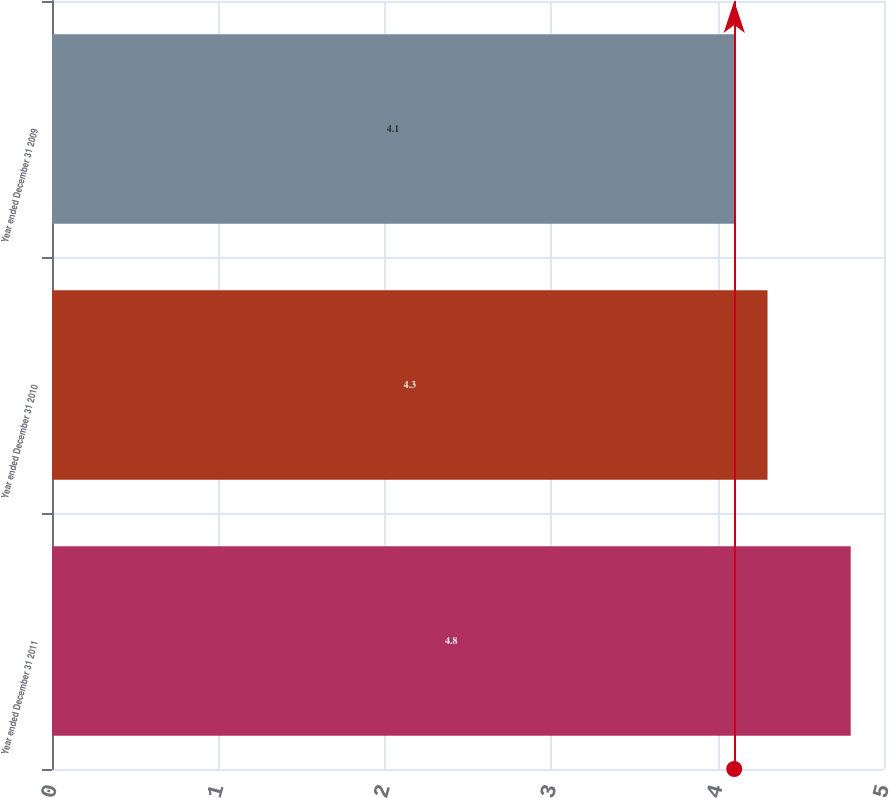Convert chart. <chart><loc_0><loc_0><loc_500><loc_500><bar_chart><fcel>Year ended December 31 2011<fcel>Year ended December 31 2010<fcel>Year ended December 31 2009<nl><fcel>4.8<fcel>4.3<fcel>4.1<nl></chart> 